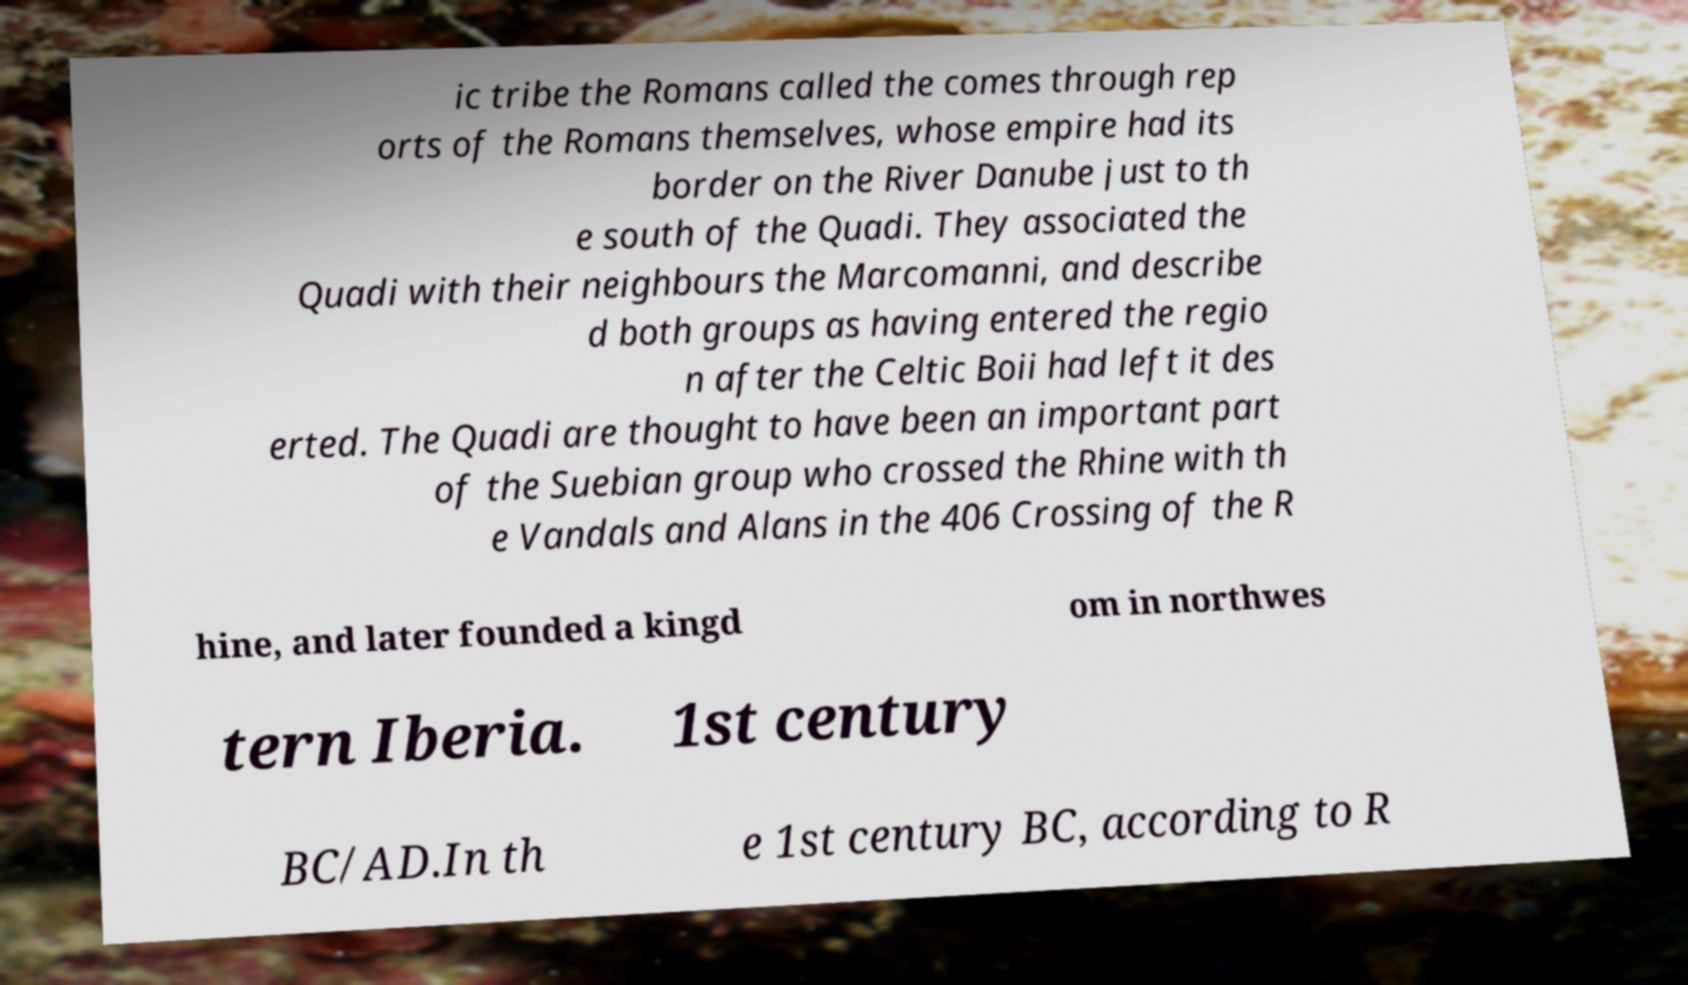What messages or text are displayed in this image? I need them in a readable, typed format. ic tribe the Romans called the comes through rep orts of the Romans themselves, whose empire had its border on the River Danube just to th e south of the Quadi. They associated the Quadi with their neighbours the Marcomanni, and describe d both groups as having entered the regio n after the Celtic Boii had left it des erted. The Quadi are thought to have been an important part of the Suebian group who crossed the Rhine with th e Vandals and Alans in the 406 Crossing of the R hine, and later founded a kingd om in northwes tern Iberia. 1st century BC/AD.In th e 1st century BC, according to R 